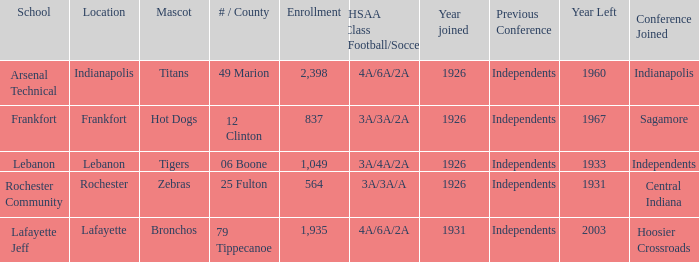What is the usual enrollment figure for schools featuring hot dogs as mascots and founded later than 1926? None. 